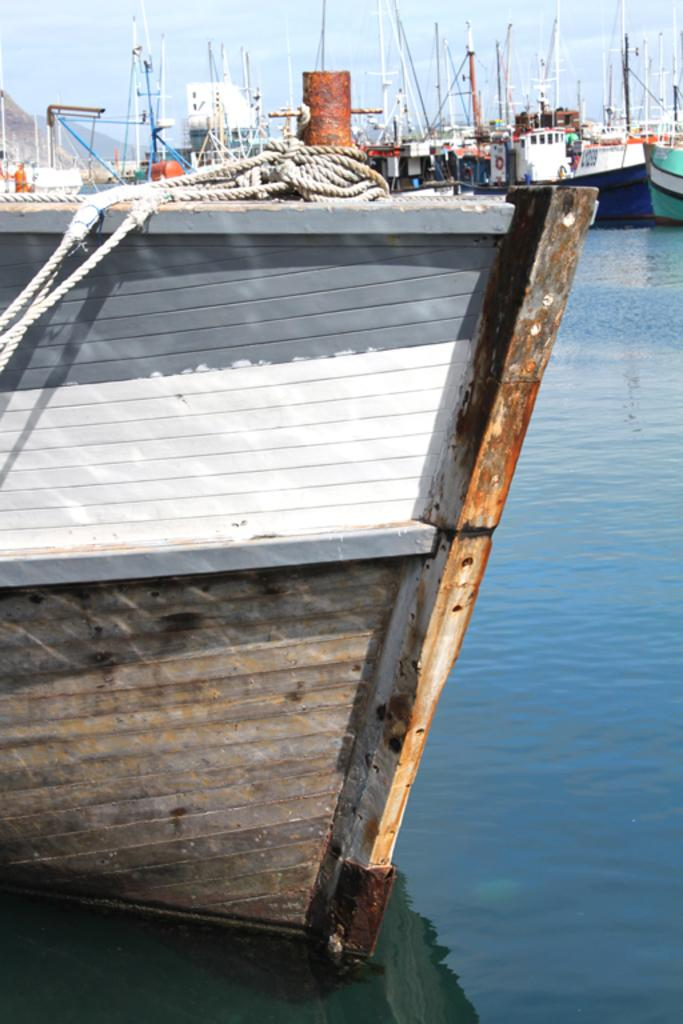What type of vehicles are in the water in the image? There are ships in the water in the image. Which ship is in the front of the image? The ship in the front of the image is the one with ropes visible. What can be seen in the background of the image? There is sky visible in the background of the image. What type of guitar can be seen on the stone in the image? There is no guitar or stone present in the image; it features ships in the water. Is there a chair visible on the ship in the front? There is no chair visible on the ship in the front; only ropes are visible. 